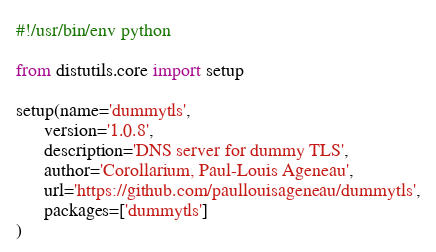Convert code to text. <code><loc_0><loc_0><loc_500><loc_500><_Python_>#!/usr/bin/env python

from distutils.core import setup

setup(name='dummytls',
      version='1.0.8',
      description='DNS server for dummy TLS',
      author='Corollarium, Paul-Louis Ageneau',
      url='https://github.com/paullouisageneau/dummytls',
      packages=['dummytls']
)
</code> 